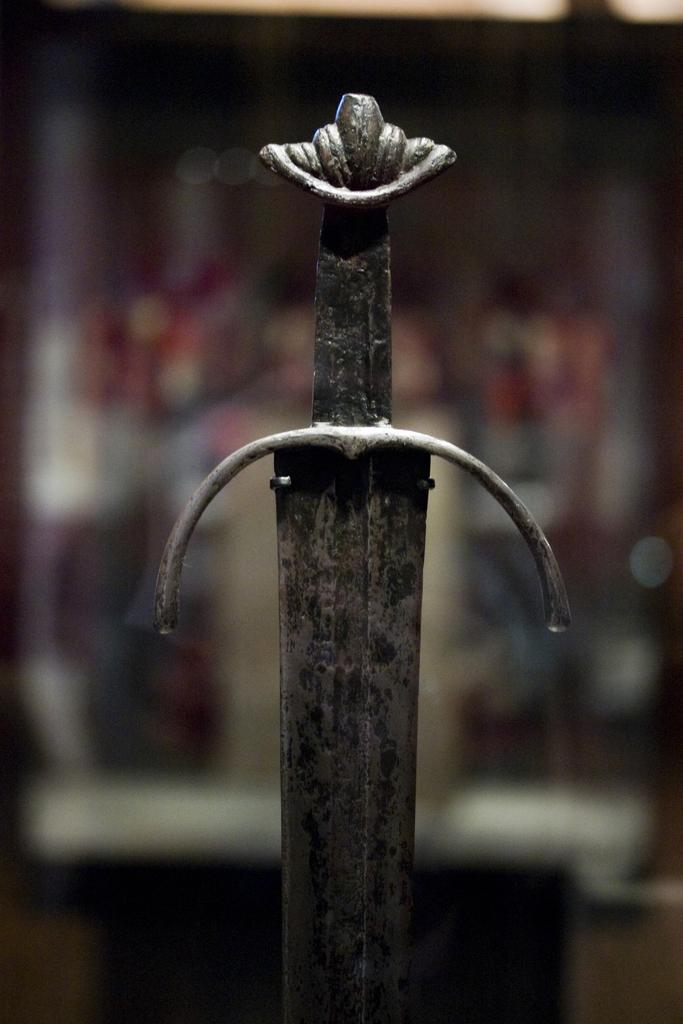What object can be seen in the image? There is a sword in the image. Can you describe the background of the image? The background of the image is blurred. What type of distribution system is depicted in the image? There is no distribution system present in the image; it features a sword and a blurred background. Can you tell me how many firemen are visible in the image? There are no firemen present in the image. 